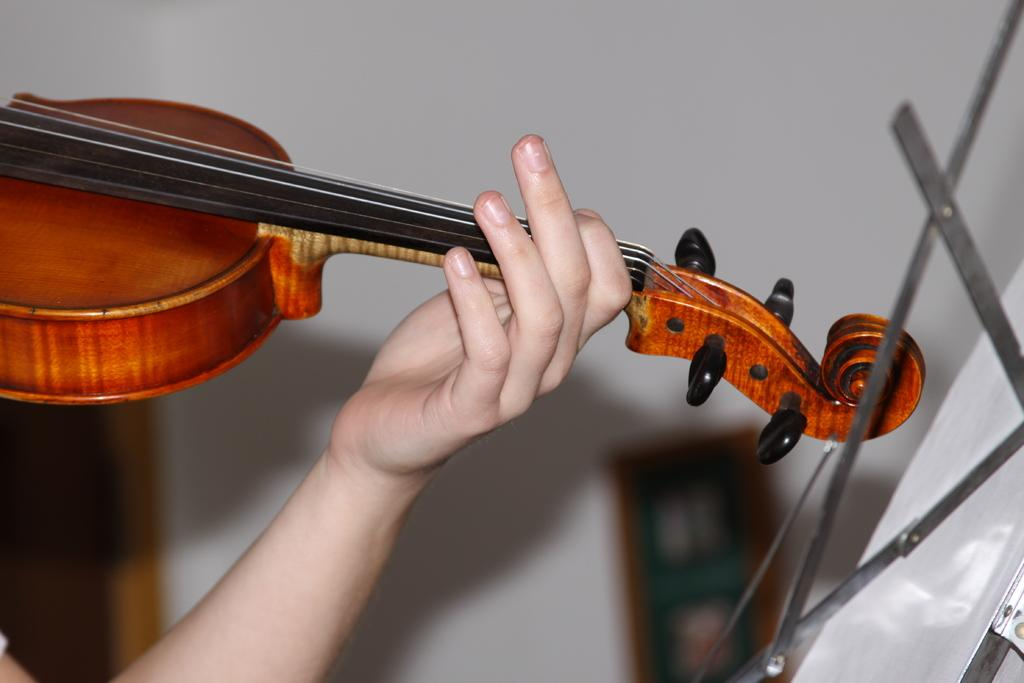What is the main subject of the image? There is a person in the image. What is the person doing in the image? The person is holding a musical instrument. What can be seen in the background of the image? There is a wall in the background of the image. What type of record can be seen on the wall in the image? There is no record present on the wall in the image. What kind of amusement can be seen in the image? There is no amusement depicted in the image; it features a person holding a musical instrument. Can you describe the wave pattern on the wall in the image? There is no wave pattern on the wall in the image; it is a plain wall. 